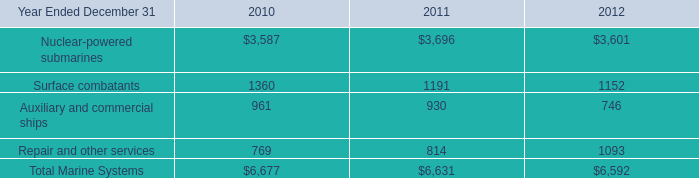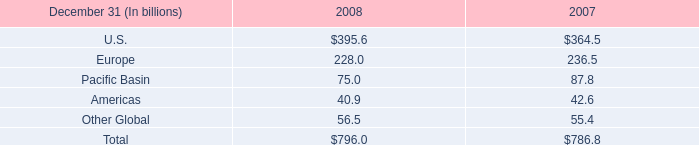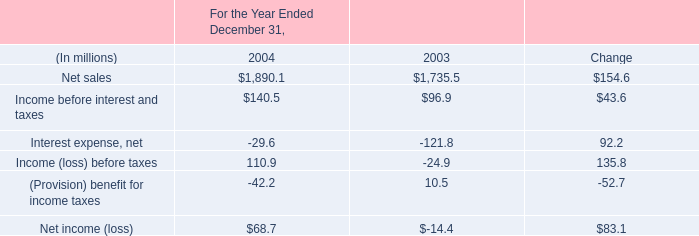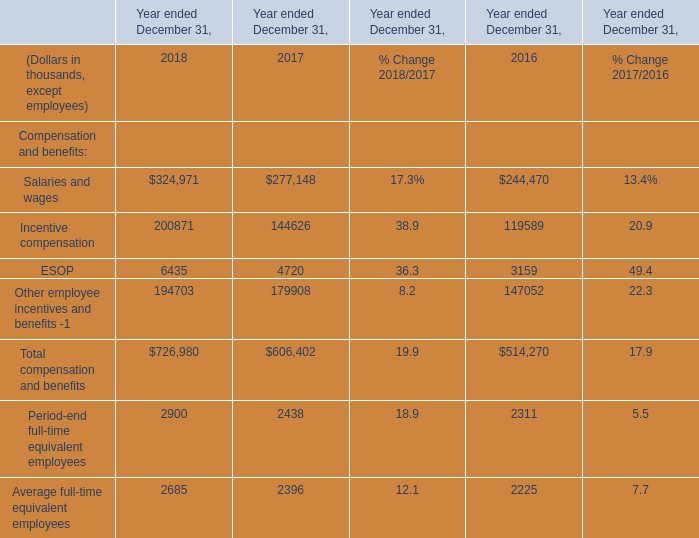What is the total amount of Surface combatants of 2011, ESOP of Year ended December 31, 2017, and Salaries and wages of Year ended December 31, 2017 ? 
Computations: ((1191.0 + 4720.0) + 277148.0)
Answer: 283059.0. 